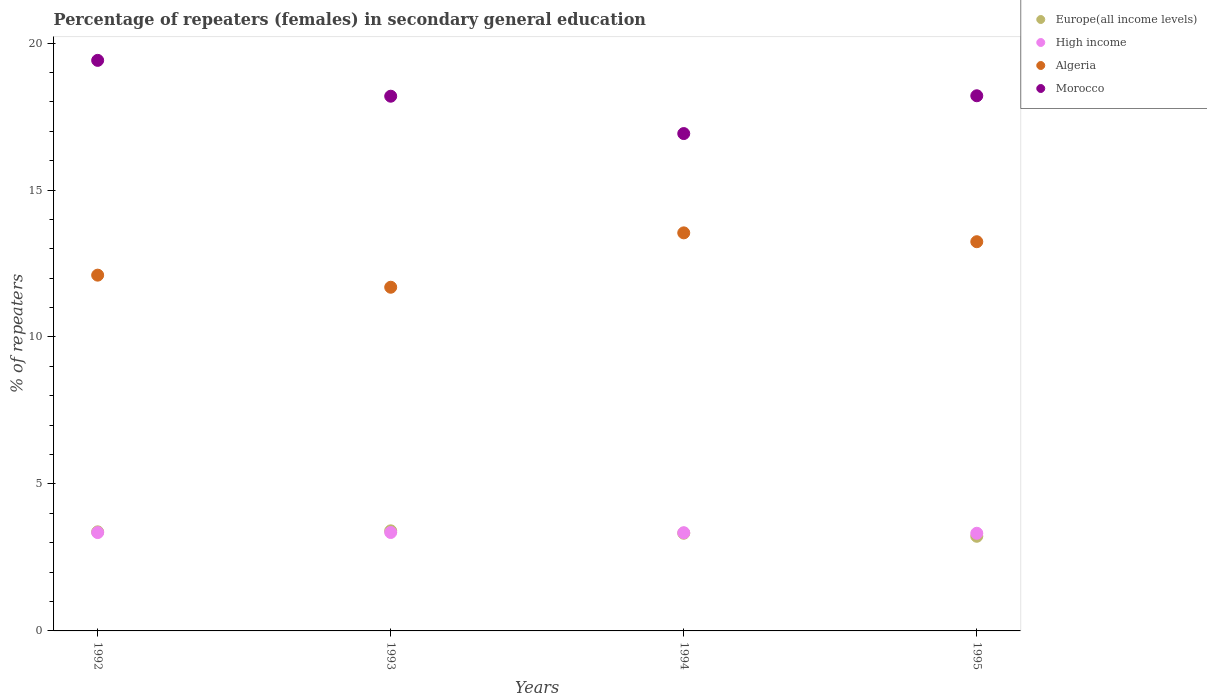How many different coloured dotlines are there?
Provide a succinct answer. 4. Is the number of dotlines equal to the number of legend labels?
Give a very brief answer. Yes. What is the percentage of female repeaters in Algeria in 1992?
Provide a short and direct response. 12.1. Across all years, what is the maximum percentage of female repeaters in Morocco?
Your response must be concise. 19.41. Across all years, what is the minimum percentage of female repeaters in Algeria?
Provide a succinct answer. 11.69. In which year was the percentage of female repeaters in High income maximum?
Your answer should be compact. 1993. What is the total percentage of female repeaters in Europe(all income levels) in the graph?
Offer a very short reply. 13.32. What is the difference between the percentage of female repeaters in Morocco in 1992 and that in 1993?
Give a very brief answer. 1.22. What is the difference between the percentage of female repeaters in Morocco in 1993 and the percentage of female repeaters in Algeria in 1995?
Offer a terse response. 4.95. What is the average percentage of female repeaters in High income per year?
Offer a terse response. 3.34. In the year 1994, what is the difference between the percentage of female repeaters in High income and percentage of female repeaters in Algeria?
Ensure brevity in your answer.  -10.2. In how many years, is the percentage of female repeaters in Morocco greater than 8 %?
Offer a very short reply. 4. What is the ratio of the percentage of female repeaters in High income in 1992 to that in 1993?
Give a very brief answer. 1. Is the percentage of female repeaters in Algeria in 1994 less than that in 1995?
Provide a short and direct response. No. Is the difference between the percentage of female repeaters in High income in 1994 and 1995 greater than the difference between the percentage of female repeaters in Algeria in 1994 and 1995?
Your answer should be compact. No. What is the difference between the highest and the second highest percentage of female repeaters in Europe(all income levels)?
Your answer should be very brief. 0.03. What is the difference between the highest and the lowest percentage of female repeaters in Morocco?
Provide a short and direct response. 2.49. Is it the case that in every year, the sum of the percentage of female repeaters in Europe(all income levels) and percentage of female repeaters in Morocco  is greater than the percentage of female repeaters in High income?
Offer a terse response. Yes. Is the percentage of female repeaters in Morocco strictly greater than the percentage of female repeaters in Algeria over the years?
Provide a succinct answer. Yes. Does the graph contain any zero values?
Ensure brevity in your answer.  No. Does the graph contain grids?
Your response must be concise. No. How many legend labels are there?
Offer a very short reply. 4. How are the legend labels stacked?
Make the answer very short. Vertical. What is the title of the graph?
Give a very brief answer. Percentage of repeaters (females) in secondary general education. What is the label or title of the Y-axis?
Your answer should be very brief. % of repeaters. What is the % of repeaters of Europe(all income levels) in 1992?
Offer a terse response. 3.37. What is the % of repeaters of High income in 1992?
Your answer should be very brief. 3.35. What is the % of repeaters in Algeria in 1992?
Ensure brevity in your answer.  12.1. What is the % of repeaters of Morocco in 1992?
Your answer should be compact. 19.41. What is the % of repeaters in Europe(all income levels) in 1993?
Ensure brevity in your answer.  3.4. What is the % of repeaters in High income in 1993?
Your answer should be compact. 3.35. What is the % of repeaters in Algeria in 1993?
Offer a very short reply. 11.69. What is the % of repeaters in Morocco in 1993?
Your answer should be compact. 18.19. What is the % of repeaters in Europe(all income levels) in 1994?
Keep it short and to the point. 3.32. What is the % of repeaters of High income in 1994?
Offer a terse response. 3.34. What is the % of repeaters in Algeria in 1994?
Your response must be concise. 13.54. What is the % of repeaters in Morocco in 1994?
Give a very brief answer. 16.92. What is the % of repeaters of Europe(all income levels) in 1995?
Ensure brevity in your answer.  3.22. What is the % of repeaters of High income in 1995?
Your answer should be very brief. 3.32. What is the % of repeaters of Algeria in 1995?
Make the answer very short. 13.24. What is the % of repeaters in Morocco in 1995?
Keep it short and to the point. 18.21. Across all years, what is the maximum % of repeaters of Europe(all income levels)?
Give a very brief answer. 3.4. Across all years, what is the maximum % of repeaters in High income?
Your answer should be compact. 3.35. Across all years, what is the maximum % of repeaters of Algeria?
Give a very brief answer. 13.54. Across all years, what is the maximum % of repeaters of Morocco?
Keep it short and to the point. 19.41. Across all years, what is the minimum % of repeaters in Europe(all income levels)?
Your answer should be compact. 3.22. Across all years, what is the minimum % of repeaters of High income?
Provide a succinct answer. 3.32. Across all years, what is the minimum % of repeaters in Algeria?
Give a very brief answer. 11.69. Across all years, what is the minimum % of repeaters of Morocco?
Offer a very short reply. 16.92. What is the total % of repeaters in Europe(all income levels) in the graph?
Ensure brevity in your answer.  13.32. What is the total % of repeaters in High income in the graph?
Your answer should be compact. 13.36. What is the total % of repeaters of Algeria in the graph?
Your response must be concise. 50.58. What is the total % of repeaters of Morocco in the graph?
Your answer should be compact. 72.73. What is the difference between the % of repeaters in Europe(all income levels) in 1992 and that in 1993?
Ensure brevity in your answer.  -0.03. What is the difference between the % of repeaters of High income in 1992 and that in 1993?
Offer a very short reply. -0. What is the difference between the % of repeaters of Algeria in 1992 and that in 1993?
Make the answer very short. 0.41. What is the difference between the % of repeaters of Morocco in 1992 and that in 1993?
Provide a short and direct response. 1.22. What is the difference between the % of repeaters in Europe(all income levels) in 1992 and that in 1994?
Make the answer very short. 0.05. What is the difference between the % of repeaters of High income in 1992 and that in 1994?
Your answer should be compact. 0. What is the difference between the % of repeaters in Algeria in 1992 and that in 1994?
Offer a terse response. -1.44. What is the difference between the % of repeaters of Morocco in 1992 and that in 1994?
Keep it short and to the point. 2.49. What is the difference between the % of repeaters in Europe(all income levels) in 1992 and that in 1995?
Offer a very short reply. 0.15. What is the difference between the % of repeaters in High income in 1992 and that in 1995?
Offer a terse response. 0.02. What is the difference between the % of repeaters in Algeria in 1992 and that in 1995?
Your answer should be compact. -1.14. What is the difference between the % of repeaters in Morocco in 1992 and that in 1995?
Make the answer very short. 1.2. What is the difference between the % of repeaters of Europe(all income levels) in 1993 and that in 1994?
Your answer should be compact. 0.08. What is the difference between the % of repeaters in High income in 1993 and that in 1994?
Provide a short and direct response. 0.01. What is the difference between the % of repeaters of Algeria in 1993 and that in 1994?
Keep it short and to the point. -1.85. What is the difference between the % of repeaters in Morocco in 1993 and that in 1994?
Offer a terse response. 1.27. What is the difference between the % of repeaters of Europe(all income levels) in 1993 and that in 1995?
Make the answer very short. 0.18. What is the difference between the % of repeaters of High income in 1993 and that in 1995?
Make the answer very short. 0.03. What is the difference between the % of repeaters of Algeria in 1993 and that in 1995?
Your answer should be very brief. -1.55. What is the difference between the % of repeaters of Morocco in 1993 and that in 1995?
Give a very brief answer. -0.02. What is the difference between the % of repeaters in Europe(all income levels) in 1994 and that in 1995?
Offer a very short reply. 0.1. What is the difference between the % of repeaters of High income in 1994 and that in 1995?
Your response must be concise. 0.02. What is the difference between the % of repeaters of Algeria in 1994 and that in 1995?
Your response must be concise. 0.3. What is the difference between the % of repeaters in Morocco in 1994 and that in 1995?
Provide a short and direct response. -1.29. What is the difference between the % of repeaters of Europe(all income levels) in 1992 and the % of repeaters of High income in 1993?
Your answer should be very brief. 0.02. What is the difference between the % of repeaters in Europe(all income levels) in 1992 and the % of repeaters in Algeria in 1993?
Offer a terse response. -8.32. What is the difference between the % of repeaters in Europe(all income levels) in 1992 and the % of repeaters in Morocco in 1993?
Ensure brevity in your answer.  -14.82. What is the difference between the % of repeaters of High income in 1992 and the % of repeaters of Algeria in 1993?
Give a very brief answer. -8.35. What is the difference between the % of repeaters of High income in 1992 and the % of repeaters of Morocco in 1993?
Give a very brief answer. -14.85. What is the difference between the % of repeaters of Algeria in 1992 and the % of repeaters of Morocco in 1993?
Give a very brief answer. -6.09. What is the difference between the % of repeaters of Europe(all income levels) in 1992 and the % of repeaters of High income in 1994?
Your answer should be very brief. 0.03. What is the difference between the % of repeaters of Europe(all income levels) in 1992 and the % of repeaters of Algeria in 1994?
Your response must be concise. -10.17. What is the difference between the % of repeaters of Europe(all income levels) in 1992 and the % of repeaters of Morocco in 1994?
Make the answer very short. -13.55. What is the difference between the % of repeaters of High income in 1992 and the % of repeaters of Algeria in 1994?
Provide a short and direct response. -10.2. What is the difference between the % of repeaters in High income in 1992 and the % of repeaters in Morocco in 1994?
Keep it short and to the point. -13.58. What is the difference between the % of repeaters of Algeria in 1992 and the % of repeaters of Morocco in 1994?
Make the answer very short. -4.82. What is the difference between the % of repeaters in Europe(all income levels) in 1992 and the % of repeaters in High income in 1995?
Your answer should be compact. 0.05. What is the difference between the % of repeaters of Europe(all income levels) in 1992 and the % of repeaters of Algeria in 1995?
Provide a short and direct response. -9.87. What is the difference between the % of repeaters of Europe(all income levels) in 1992 and the % of repeaters of Morocco in 1995?
Keep it short and to the point. -14.84. What is the difference between the % of repeaters in High income in 1992 and the % of repeaters in Algeria in 1995?
Give a very brief answer. -9.9. What is the difference between the % of repeaters in High income in 1992 and the % of repeaters in Morocco in 1995?
Make the answer very short. -14.86. What is the difference between the % of repeaters in Algeria in 1992 and the % of repeaters in Morocco in 1995?
Offer a terse response. -6.1. What is the difference between the % of repeaters of Europe(all income levels) in 1993 and the % of repeaters of High income in 1994?
Ensure brevity in your answer.  0.06. What is the difference between the % of repeaters of Europe(all income levels) in 1993 and the % of repeaters of Algeria in 1994?
Make the answer very short. -10.14. What is the difference between the % of repeaters of Europe(all income levels) in 1993 and the % of repeaters of Morocco in 1994?
Your response must be concise. -13.52. What is the difference between the % of repeaters in High income in 1993 and the % of repeaters in Algeria in 1994?
Offer a terse response. -10.19. What is the difference between the % of repeaters of High income in 1993 and the % of repeaters of Morocco in 1994?
Your answer should be compact. -13.57. What is the difference between the % of repeaters of Algeria in 1993 and the % of repeaters of Morocco in 1994?
Provide a succinct answer. -5.23. What is the difference between the % of repeaters in Europe(all income levels) in 1993 and the % of repeaters in High income in 1995?
Offer a very short reply. 0.08. What is the difference between the % of repeaters in Europe(all income levels) in 1993 and the % of repeaters in Algeria in 1995?
Provide a short and direct response. -9.84. What is the difference between the % of repeaters of Europe(all income levels) in 1993 and the % of repeaters of Morocco in 1995?
Make the answer very short. -14.8. What is the difference between the % of repeaters in High income in 1993 and the % of repeaters in Algeria in 1995?
Offer a terse response. -9.89. What is the difference between the % of repeaters of High income in 1993 and the % of repeaters of Morocco in 1995?
Keep it short and to the point. -14.86. What is the difference between the % of repeaters in Algeria in 1993 and the % of repeaters in Morocco in 1995?
Your answer should be very brief. -6.51. What is the difference between the % of repeaters in Europe(all income levels) in 1994 and the % of repeaters in High income in 1995?
Provide a short and direct response. 0. What is the difference between the % of repeaters in Europe(all income levels) in 1994 and the % of repeaters in Algeria in 1995?
Offer a very short reply. -9.92. What is the difference between the % of repeaters of Europe(all income levels) in 1994 and the % of repeaters of Morocco in 1995?
Keep it short and to the point. -14.88. What is the difference between the % of repeaters in High income in 1994 and the % of repeaters in Algeria in 1995?
Your answer should be compact. -9.9. What is the difference between the % of repeaters in High income in 1994 and the % of repeaters in Morocco in 1995?
Give a very brief answer. -14.87. What is the difference between the % of repeaters in Algeria in 1994 and the % of repeaters in Morocco in 1995?
Keep it short and to the point. -4.66. What is the average % of repeaters of Europe(all income levels) per year?
Your answer should be compact. 3.33. What is the average % of repeaters of High income per year?
Provide a succinct answer. 3.34. What is the average % of repeaters in Algeria per year?
Your answer should be very brief. 12.65. What is the average % of repeaters of Morocco per year?
Your answer should be compact. 18.18. In the year 1992, what is the difference between the % of repeaters in Europe(all income levels) and % of repeaters in High income?
Ensure brevity in your answer.  0.02. In the year 1992, what is the difference between the % of repeaters in Europe(all income levels) and % of repeaters in Algeria?
Keep it short and to the point. -8.73. In the year 1992, what is the difference between the % of repeaters in Europe(all income levels) and % of repeaters in Morocco?
Give a very brief answer. -16.04. In the year 1992, what is the difference between the % of repeaters of High income and % of repeaters of Algeria?
Make the answer very short. -8.76. In the year 1992, what is the difference between the % of repeaters of High income and % of repeaters of Morocco?
Ensure brevity in your answer.  -16.07. In the year 1992, what is the difference between the % of repeaters in Algeria and % of repeaters in Morocco?
Your response must be concise. -7.31. In the year 1993, what is the difference between the % of repeaters in Europe(all income levels) and % of repeaters in High income?
Offer a terse response. 0.06. In the year 1993, what is the difference between the % of repeaters in Europe(all income levels) and % of repeaters in Algeria?
Your answer should be very brief. -8.29. In the year 1993, what is the difference between the % of repeaters in Europe(all income levels) and % of repeaters in Morocco?
Provide a succinct answer. -14.79. In the year 1993, what is the difference between the % of repeaters in High income and % of repeaters in Algeria?
Ensure brevity in your answer.  -8.34. In the year 1993, what is the difference between the % of repeaters in High income and % of repeaters in Morocco?
Ensure brevity in your answer.  -14.84. In the year 1993, what is the difference between the % of repeaters in Algeria and % of repeaters in Morocco?
Provide a short and direct response. -6.5. In the year 1994, what is the difference between the % of repeaters in Europe(all income levels) and % of repeaters in High income?
Offer a very short reply. -0.02. In the year 1994, what is the difference between the % of repeaters in Europe(all income levels) and % of repeaters in Algeria?
Give a very brief answer. -10.22. In the year 1994, what is the difference between the % of repeaters in Europe(all income levels) and % of repeaters in Morocco?
Keep it short and to the point. -13.6. In the year 1994, what is the difference between the % of repeaters in High income and % of repeaters in Algeria?
Your response must be concise. -10.2. In the year 1994, what is the difference between the % of repeaters of High income and % of repeaters of Morocco?
Your response must be concise. -13.58. In the year 1994, what is the difference between the % of repeaters in Algeria and % of repeaters in Morocco?
Offer a terse response. -3.38. In the year 1995, what is the difference between the % of repeaters in Europe(all income levels) and % of repeaters in High income?
Ensure brevity in your answer.  -0.1. In the year 1995, what is the difference between the % of repeaters of Europe(all income levels) and % of repeaters of Algeria?
Your answer should be very brief. -10.02. In the year 1995, what is the difference between the % of repeaters of Europe(all income levels) and % of repeaters of Morocco?
Your answer should be compact. -14.99. In the year 1995, what is the difference between the % of repeaters in High income and % of repeaters in Algeria?
Give a very brief answer. -9.92. In the year 1995, what is the difference between the % of repeaters in High income and % of repeaters in Morocco?
Your answer should be compact. -14.88. In the year 1995, what is the difference between the % of repeaters of Algeria and % of repeaters of Morocco?
Offer a terse response. -4.97. What is the ratio of the % of repeaters in Algeria in 1992 to that in 1993?
Your answer should be very brief. 1.04. What is the ratio of the % of repeaters of Morocco in 1992 to that in 1993?
Ensure brevity in your answer.  1.07. What is the ratio of the % of repeaters in Europe(all income levels) in 1992 to that in 1994?
Provide a short and direct response. 1.01. What is the ratio of the % of repeaters in High income in 1992 to that in 1994?
Provide a short and direct response. 1. What is the ratio of the % of repeaters in Algeria in 1992 to that in 1994?
Your answer should be very brief. 0.89. What is the ratio of the % of repeaters of Morocco in 1992 to that in 1994?
Give a very brief answer. 1.15. What is the ratio of the % of repeaters of Europe(all income levels) in 1992 to that in 1995?
Ensure brevity in your answer.  1.05. What is the ratio of the % of repeaters of High income in 1992 to that in 1995?
Give a very brief answer. 1.01. What is the ratio of the % of repeaters of Algeria in 1992 to that in 1995?
Provide a short and direct response. 0.91. What is the ratio of the % of repeaters of Morocco in 1992 to that in 1995?
Give a very brief answer. 1.07. What is the ratio of the % of repeaters of Europe(all income levels) in 1993 to that in 1994?
Your answer should be compact. 1.02. What is the ratio of the % of repeaters of High income in 1993 to that in 1994?
Your answer should be compact. 1. What is the ratio of the % of repeaters of Algeria in 1993 to that in 1994?
Give a very brief answer. 0.86. What is the ratio of the % of repeaters of Morocco in 1993 to that in 1994?
Your answer should be compact. 1.08. What is the ratio of the % of repeaters in Europe(all income levels) in 1993 to that in 1995?
Give a very brief answer. 1.06. What is the ratio of the % of repeaters in High income in 1993 to that in 1995?
Keep it short and to the point. 1.01. What is the ratio of the % of repeaters of Algeria in 1993 to that in 1995?
Ensure brevity in your answer.  0.88. What is the ratio of the % of repeaters in Europe(all income levels) in 1994 to that in 1995?
Your answer should be compact. 1.03. What is the ratio of the % of repeaters in Algeria in 1994 to that in 1995?
Keep it short and to the point. 1.02. What is the ratio of the % of repeaters of Morocco in 1994 to that in 1995?
Keep it short and to the point. 0.93. What is the difference between the highest and the second highest % of repeaters in Europe(all income levels)?
Offer a very short reply. 0.03. What is the difference between the highest and the second highest % of repeaters in High income?
Make the answer very short. 0. What is the difference between the highest and the second highest % of repeaters of Algeria?
Your answer should be compact. 0.3. What is the difference between the highest and the second highest % of repeaters of Morocco?
Provide a succinct answer. 1.2. What is the difference between the highest and the lowest % of repeaters in Europe(all income levels)?
Your answer should be very brief. 0.18. What is the difference between the highest and the lowest % of repeaters of High income?
Ensure brevity in your answer.  0.03. What is the difference between the highest and the lowest % of repeaters of Algeria?
Provide a short and direct response. 1.85. What is the difference between the highest and the lowest % of repeaters in Morocco?
Your response must be concise. 2.49. 